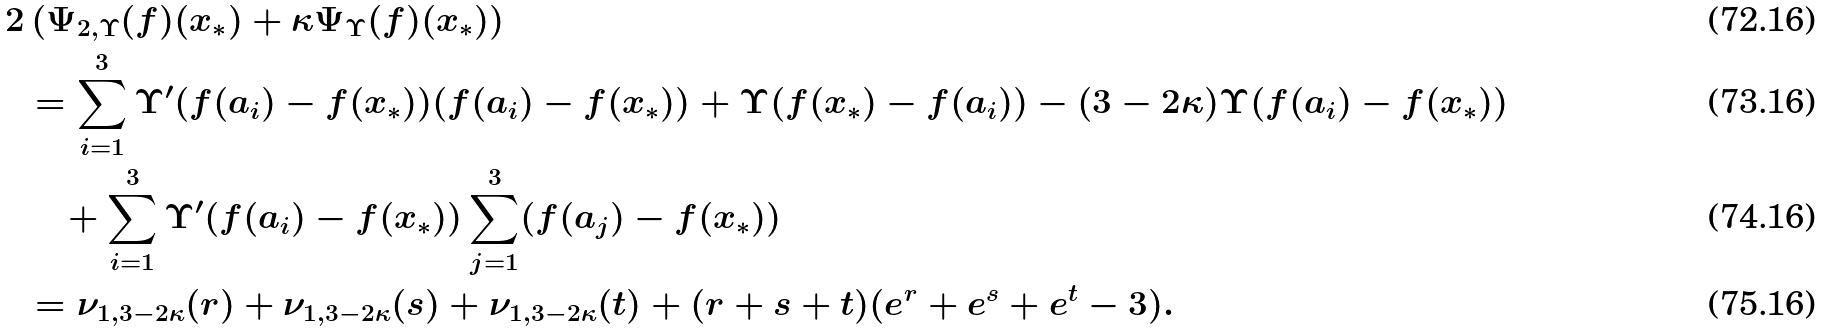<formula> <loc_0><loc_0><loc_500><loc_500>2 & \left ( \Psi _ { 2 , \Upsilon } ( f ) ( x _ { * } ) + \kappa \Psi _ { \Upsilon } ( f ) ( x _ { * } ) \right ) \\ & = \sum _ { i = 1 } ^ { 3 } \Upsilon ^ { \prime } ( f ( a _ { i } ) - f ( x _ { * } ) ) ( f ( a _ { i } ) - f ( x _ { * } ) ) + \Upsilon ( f ( x _ { * } ) - f ( a _ { i } ) ) - ( 3 - 2 \kappa ) \Upsilon ( f ( a _ { i } ) - f ( x _ { * } ) ) \\ & \quad + \sum _ { i = 1 } ^ { 3 } \Upsilon ^ { \prime } ( f ( a _ { i } ) - f ( x _ { * } ) ) \sum _ { j = 1 } ^ { 3 } ( f ( a _ { j } ) - f ( x _ { * } ) ) \\ & = \nu _ { 1 , 3 - 2 \kappa } ( r ) + \nu _ { 1 , 3 - 2 \kappa } ( s ) + \nu _ { 1 , 3 - 2 \kappa } ( t ) + ( r + s + t ) ( e ^ { r } + e ^ { s } + e ^ { t } - 3 ) .</formula> 